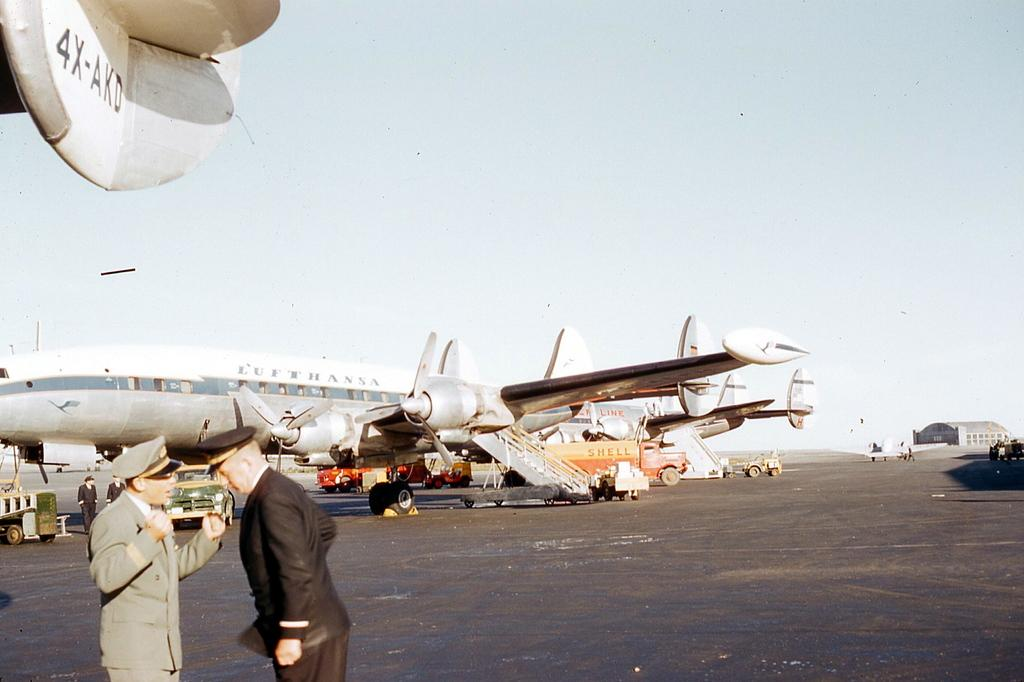What is the main subject of the image? The main subject of the image is a plane. Are there any other subjects or objects in the image? Yes, there are people, vehicles, and a building in the image. What type of caption is written on the side of the plane in the image? There is no caption written on the side of the plane in the image. Can you see any cattle in the image? There are no cattle present in the image. 